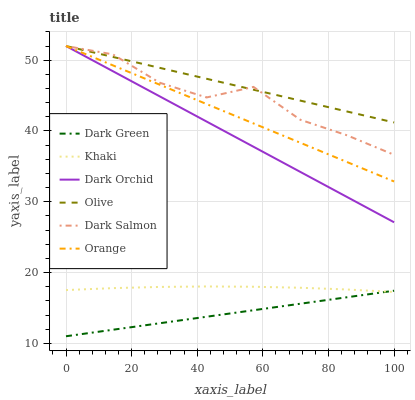Does Dark Green have the minimum area under the curve?
Answer yes or no. Yes. Does Olive have the maximum area under the curve?
Answer yes or no. Yes. Does Dark Salmon have the minimum area under the curve?
Answer yes or no. No. Does Dark Salmon have the maximum area under the curve?
Answer yes or no. No. Is Dark Green the smoothest?
Answer yes or no. Yes. Is Dark Salmon the roughest?
Answer yes or no. Yes. Is Dark Orchid the smoothest?
Answer yes or no. No. Is Dark Orchid the roughest?
Answer yes or no. No. Does Dark Green have the lowest value?
Answer yes or no. Yes. Does Dark Salmon have the lowest value?
Answer yes or no. No. Does Olive have the highest value?
Answer yes or no. Yes. Does Dark Green have the highest value?
Answer yes or no. No. Is Dark Green less than Orange?
Answer yes or no. Yes. Is Dark Orchid greater than Dark Green?
Answer yes or no. Yes. Does Orange intersect Dark Orchid?
Answer yes or no. Yes. Is Orange less than Dark Orchid?
Answer yes or no. No. Is Orange greater than Dark Orchid?
Answer yes or no. No. Does Dark Green intersect Orange?
Answer yes or no. No. 